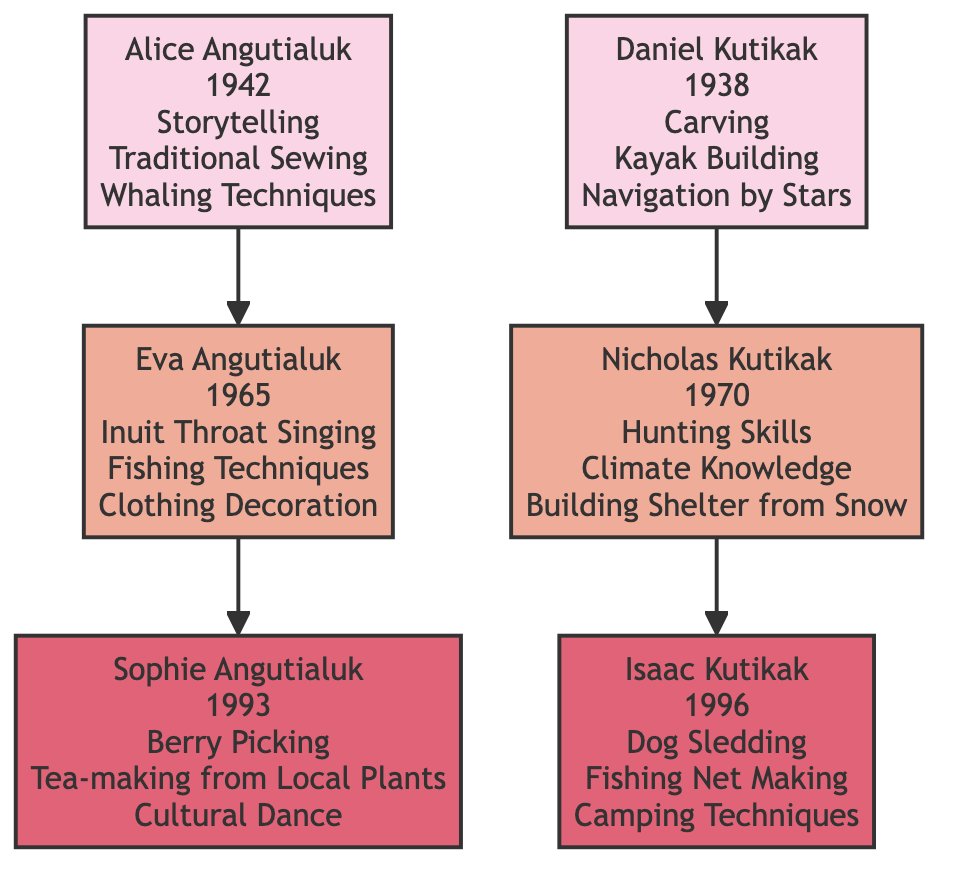What cultural practice is associated with Alice Angutialuk? According to the diagram, Alice Angutialuk is associated with three cultural practices: Storytelling, Traditional Sewing, and Whaling Techniques. Thus, any of these practices could be noted, but the question just asks for one, which can be taken as the first listed.
Answer: Storytelling Who is the child of Daniel Kutikak? The diagram shows that Nicholas Kutikak is directly linked below Daniel Kutikak, indicating that he is the child of Daniel Kutikak.
Answer: Nicholas Kutikak How many grandchildren are shown in the diagram? The diagram displays two grandchildren: Sophie Angutialuk and Isaac Kutikak. By counting the nodes listed under the Grandchildren section, we find that there are a total of 2 grandchildren.
Answer: 2 What cultural practice does Isaac Kutikak engage in? The diagram specifies that Isaac Kutikak is associated with Dog Sledding, Fishing Net Making, and Camping Techniques. The question can be answered with any of these associated practices but only requires one.
Answer: Dog Sledding Which elder's child practices Inuit Throat Singing? The diagram indicates that Eva Angutialuk is the child of Alice Angutialuk and is associated with the cultural practice of Inuit Throat Singing. Therefore, the elder associated with her is Alice Angutialuk.
Answer: Alice Angutialuk What year was Sophie Angutialuk born? By looking at the diagram, Sophie Angutialuk is shown to have been born in 1993, which is clearly labeled next to her name in the Grandchildren section.
Answer: 1993 Which cultural practice is shared by both Eva Angutialuk and Nicholas Kutikak? Upon reviewing the cultural practices listed for both children, it’s evident that they do not have a shared practice. Eva's practices include Inuit Throat Singing, Fishing Techniques, and Clothing Decoration, while Nicholas's include Hunting Skills, Climate Knowledge, and Building Shelter from Snow. Therefore, this indicates there is no overlap.
Answer: None How many cultural practices are attributed to Daniel Kutikak? The diagram lists three cultural practices that Daniel Kutikak engages in: Carving, Kayak Building, and Navigation by Stars. Therefore, by counting these practices, we see that three are attributed to him.
Answer: 3 